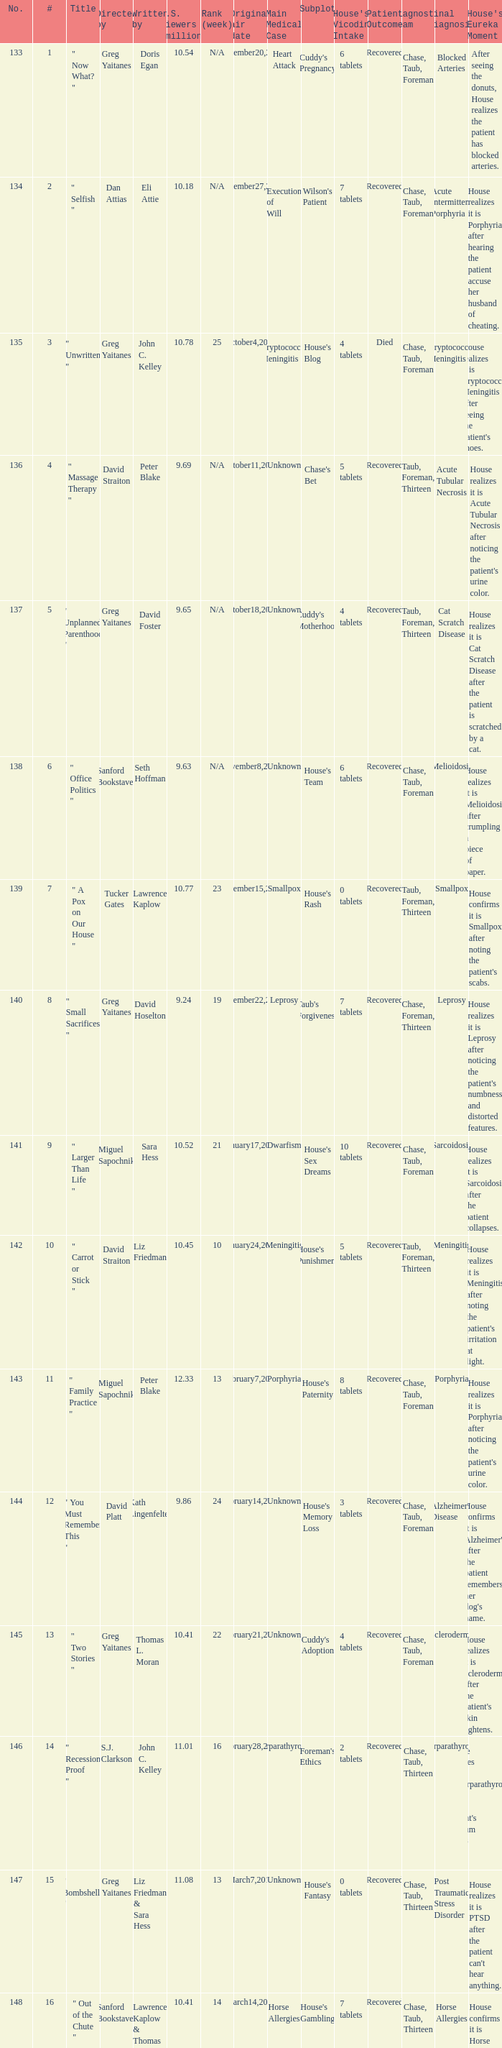Where did the episode rank that was written by thomas l. moran? 22.0. 